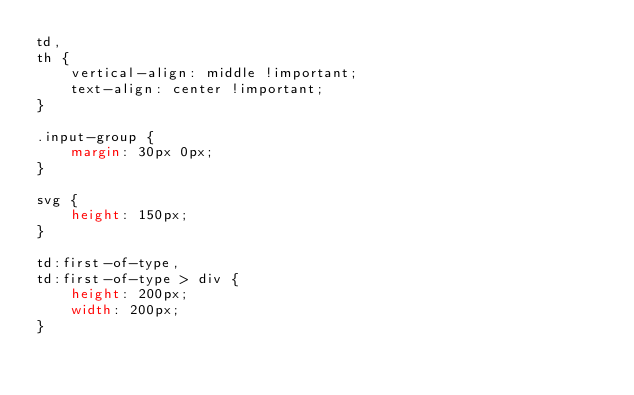<code> <loc_0><loc_0><loc_500><loc_500><_CSS_>td,
th {
    vertical-align: middle !important;
    text-align: center !important;
}

.input-group {
    margin: 30px 0px;
}

svg {
    height: 150px;
}

td:first-of-type,
td:first-of-type > div {
    height: 200px;
    width: 200px;
}
</code> 